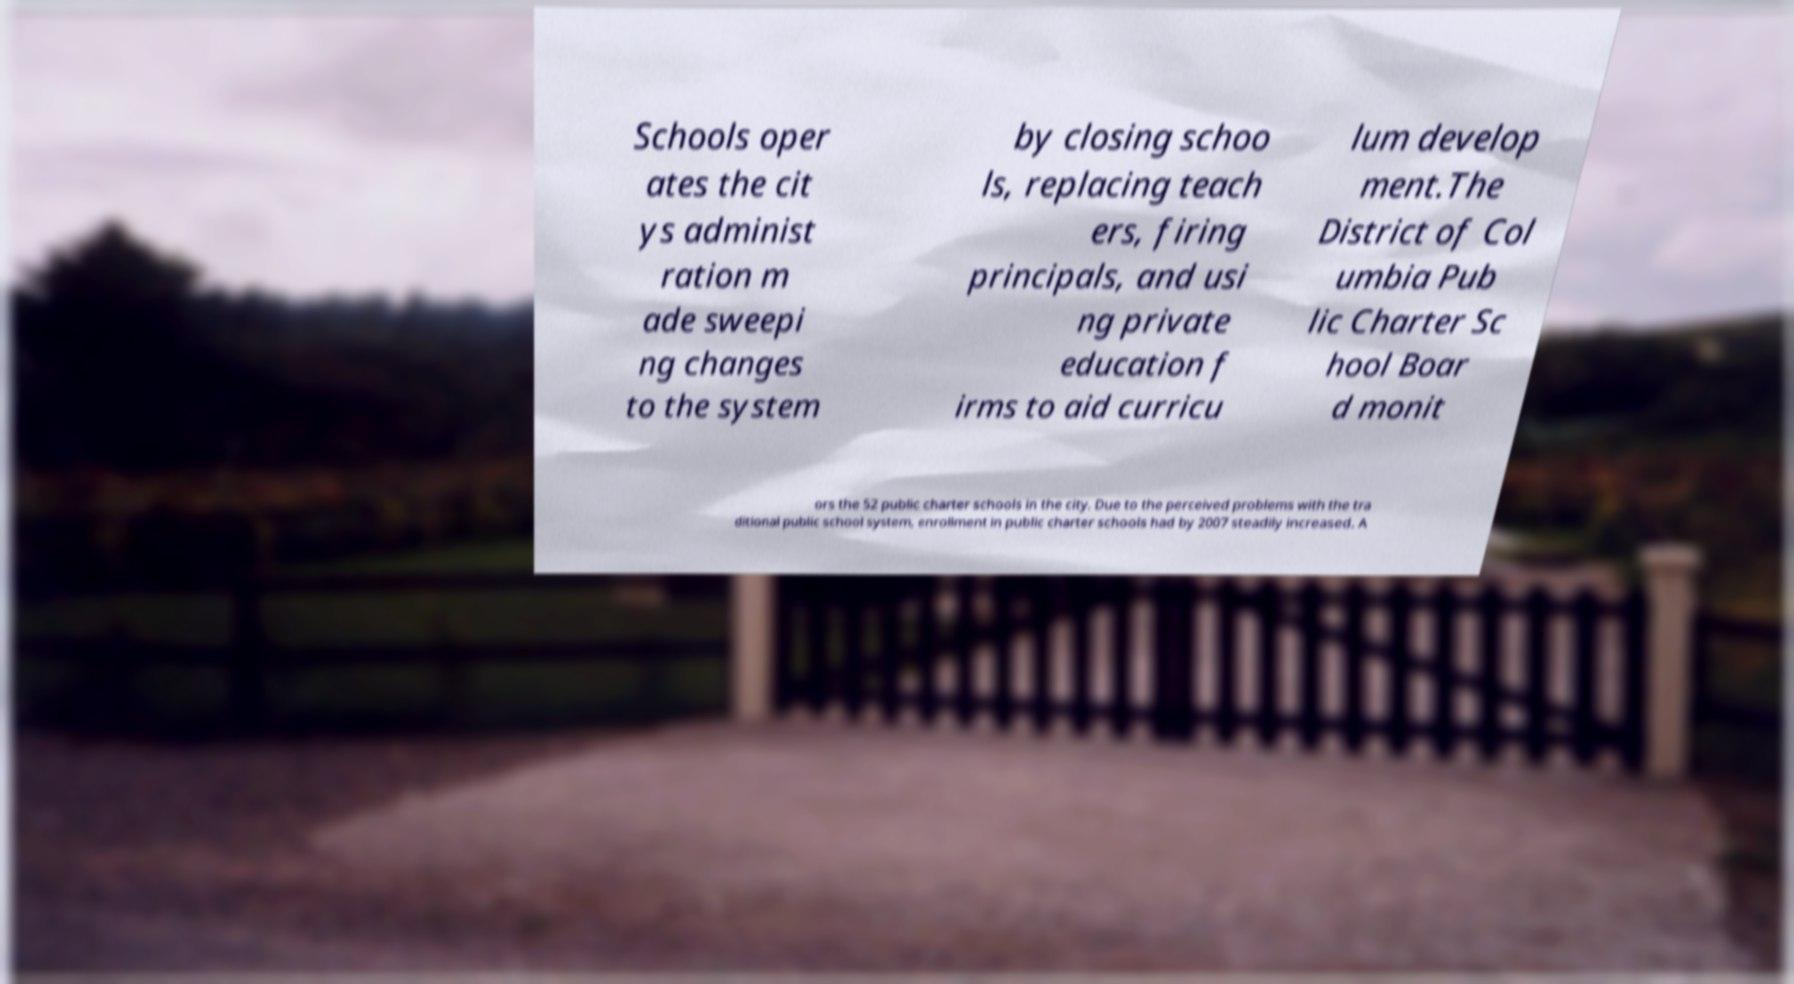What messages or text are displayed in this image? I need them in a readable, typed format. Schools oper ates the cit ys administ ration m ade sweepi ng changes to the system by closing schoo ls, replacing teach ers, firing principals, and usi ng private education f irms to aid curricu lum develop ment.The District of Col umbia Pub lic Charter Sc hool Boar d monit ors the 52 public charter schools in the city. Due to the perceived problems with the tra ditional public school system, enrollment in public charter schools had by 2007 steadily increased. A 